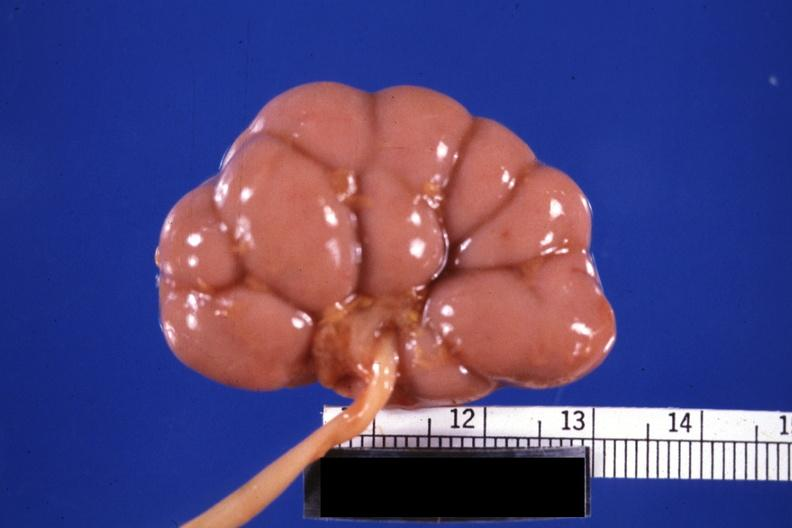what does this image show?
Answer the question using a single word or phrase. Fixed tissue good example small kidney 